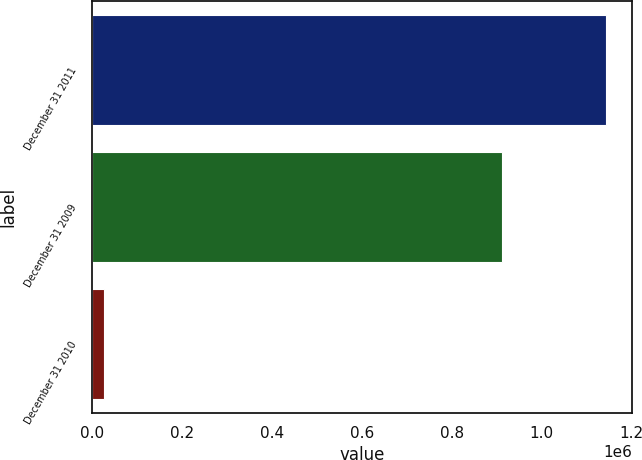<chart> <loc_0><loc_0><loc_500><loc_500><bar_chart><fcel>December 31 2011<fcel>December 31 2009<fcel>December 31 2010<nl><fcel>1.14301e+06<fcel>912753<fcel>27101<nl></chart> 